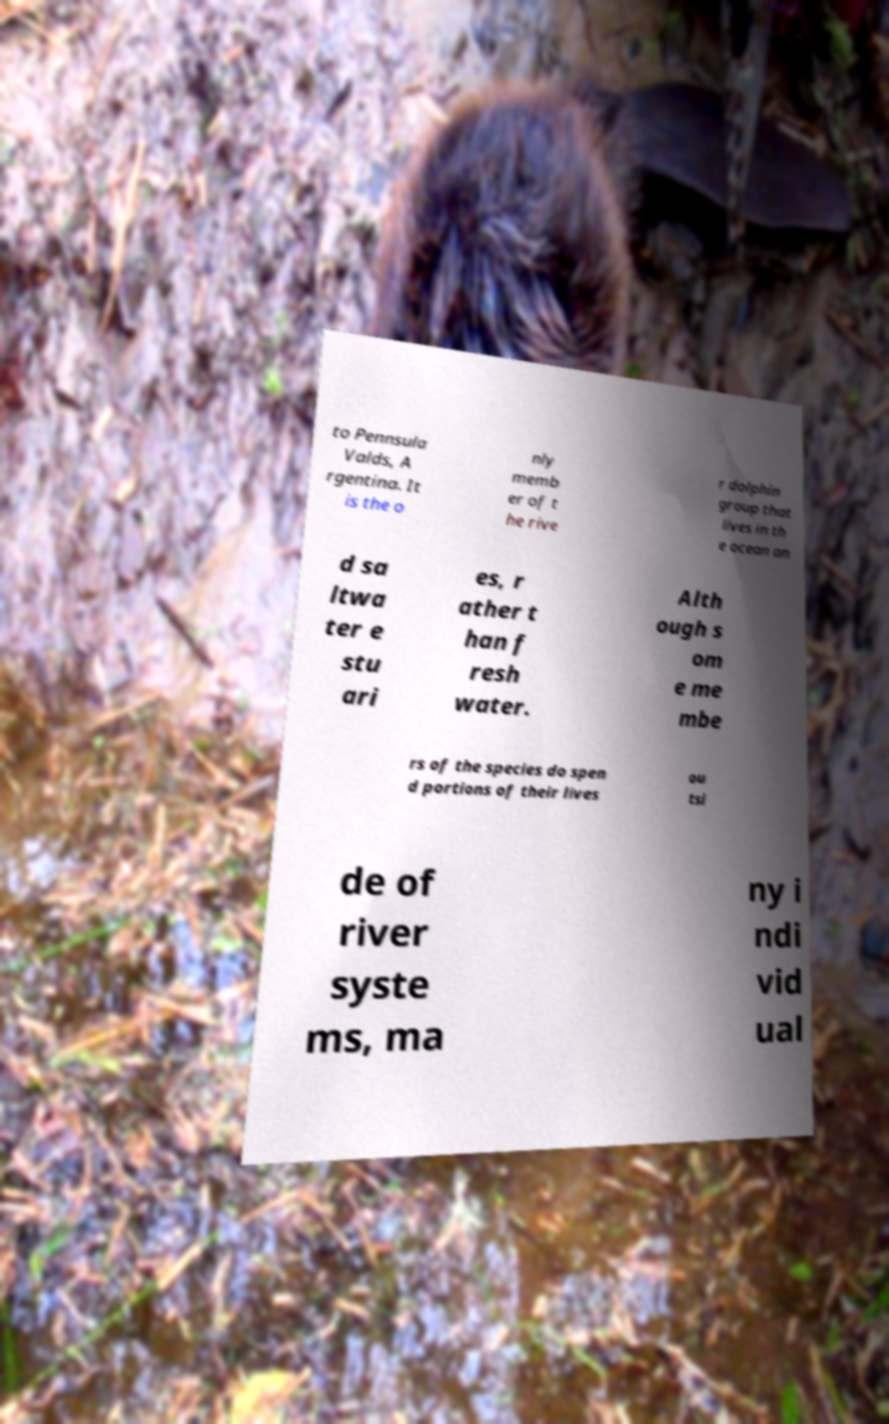Can you accurately transcribe the text from the provided image for me? to Pennsula Valds, A rgentina. It is the o nly memb er of t he rive r dolphin group that lives in th e ocean an d sa ltwa ter e stu ari es, r ather t han f resh water. Alth ough s om e me mbe rs of the species do spen d portions of their lives ou tsi de of river syste ms, ma ny i ndi vid ual 